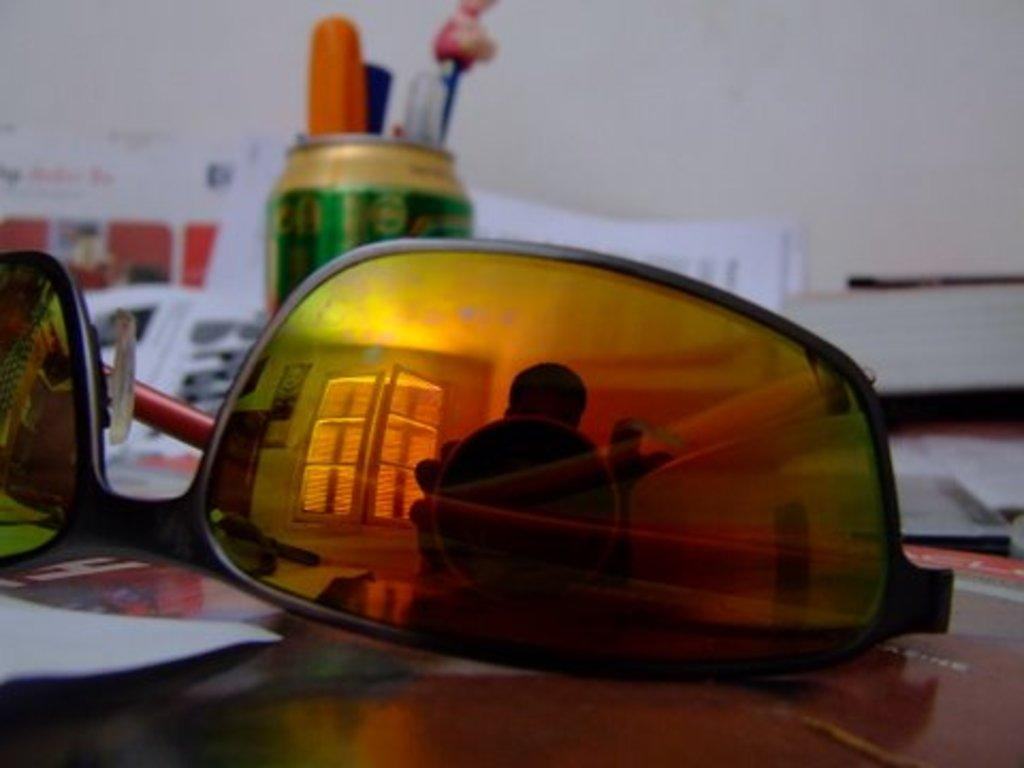What objects are on the table in the image? There are papers, pens in a tin, and spectacles on the table in the image. What might be used for writing on the papers? The pens in the tin might be used for writing on the papers. What can be seen in the reflections of the image? There is a reflection of a person, a window, and a wall in the image. What type of yam is being harvested by the laborer in the image? There is no laborer or yam present in the image; it features a table with various objects and reflections. 